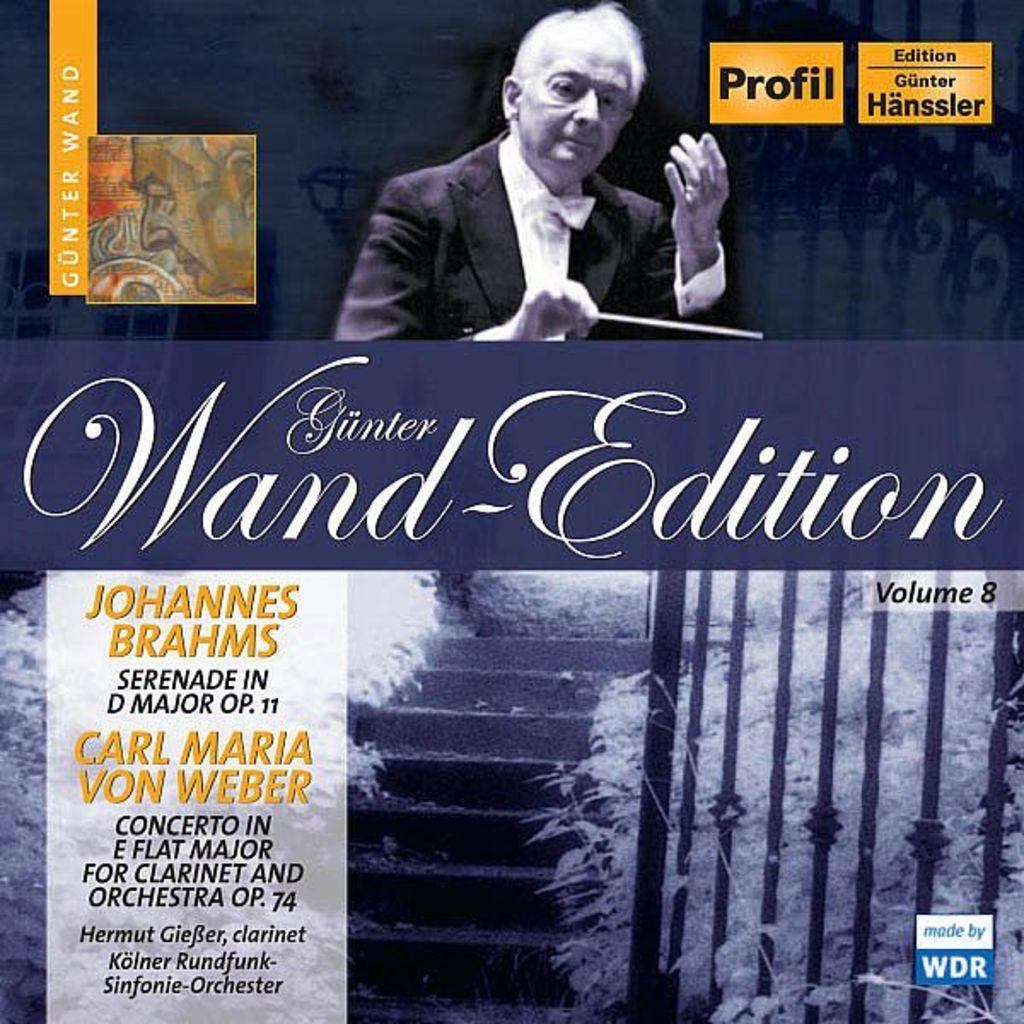<image>
Create a compact narrative representing the image presented. A concert that features Brahms music is advertised. 